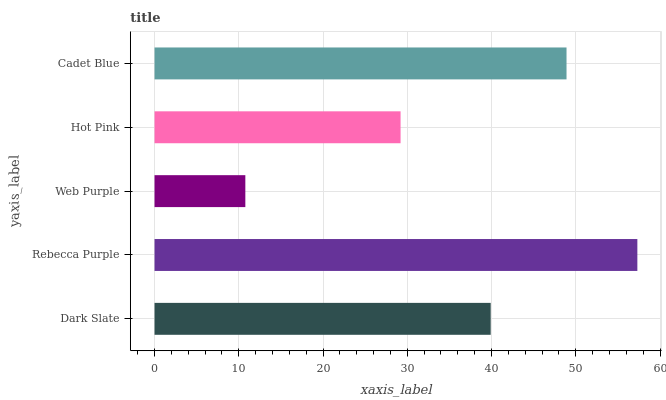Is Web Purple the minimum?
Answer yes or no. Yes. Is Rebecca Purple the maximum?
Answer yes or no. Yes. Is Rebecca Purple the minimum?
Answer yes or no. No. Is Web Purple the maximum?
Answer yes or no. No. Is Rebecca Purple greater than Web Purple?
Answer yes or no. Yes. Is Web Purple less than Rebecca Purple?
Answer yes or no. Yes. Is Web Purple greater than Rebecca Purple?
Answer yes or no. No. Is Rebecca Purple less than Web Purple?
Answer yes or no. No. Is Dark Slate the high median?
Answer yes or no. Yes. Is Dark Slate the low median?
Answer yes or no. Yes. Is Hot Pink the high median?
Answer yes or no. No. Is Web Purple the low median?
Answer yes or no. No. 